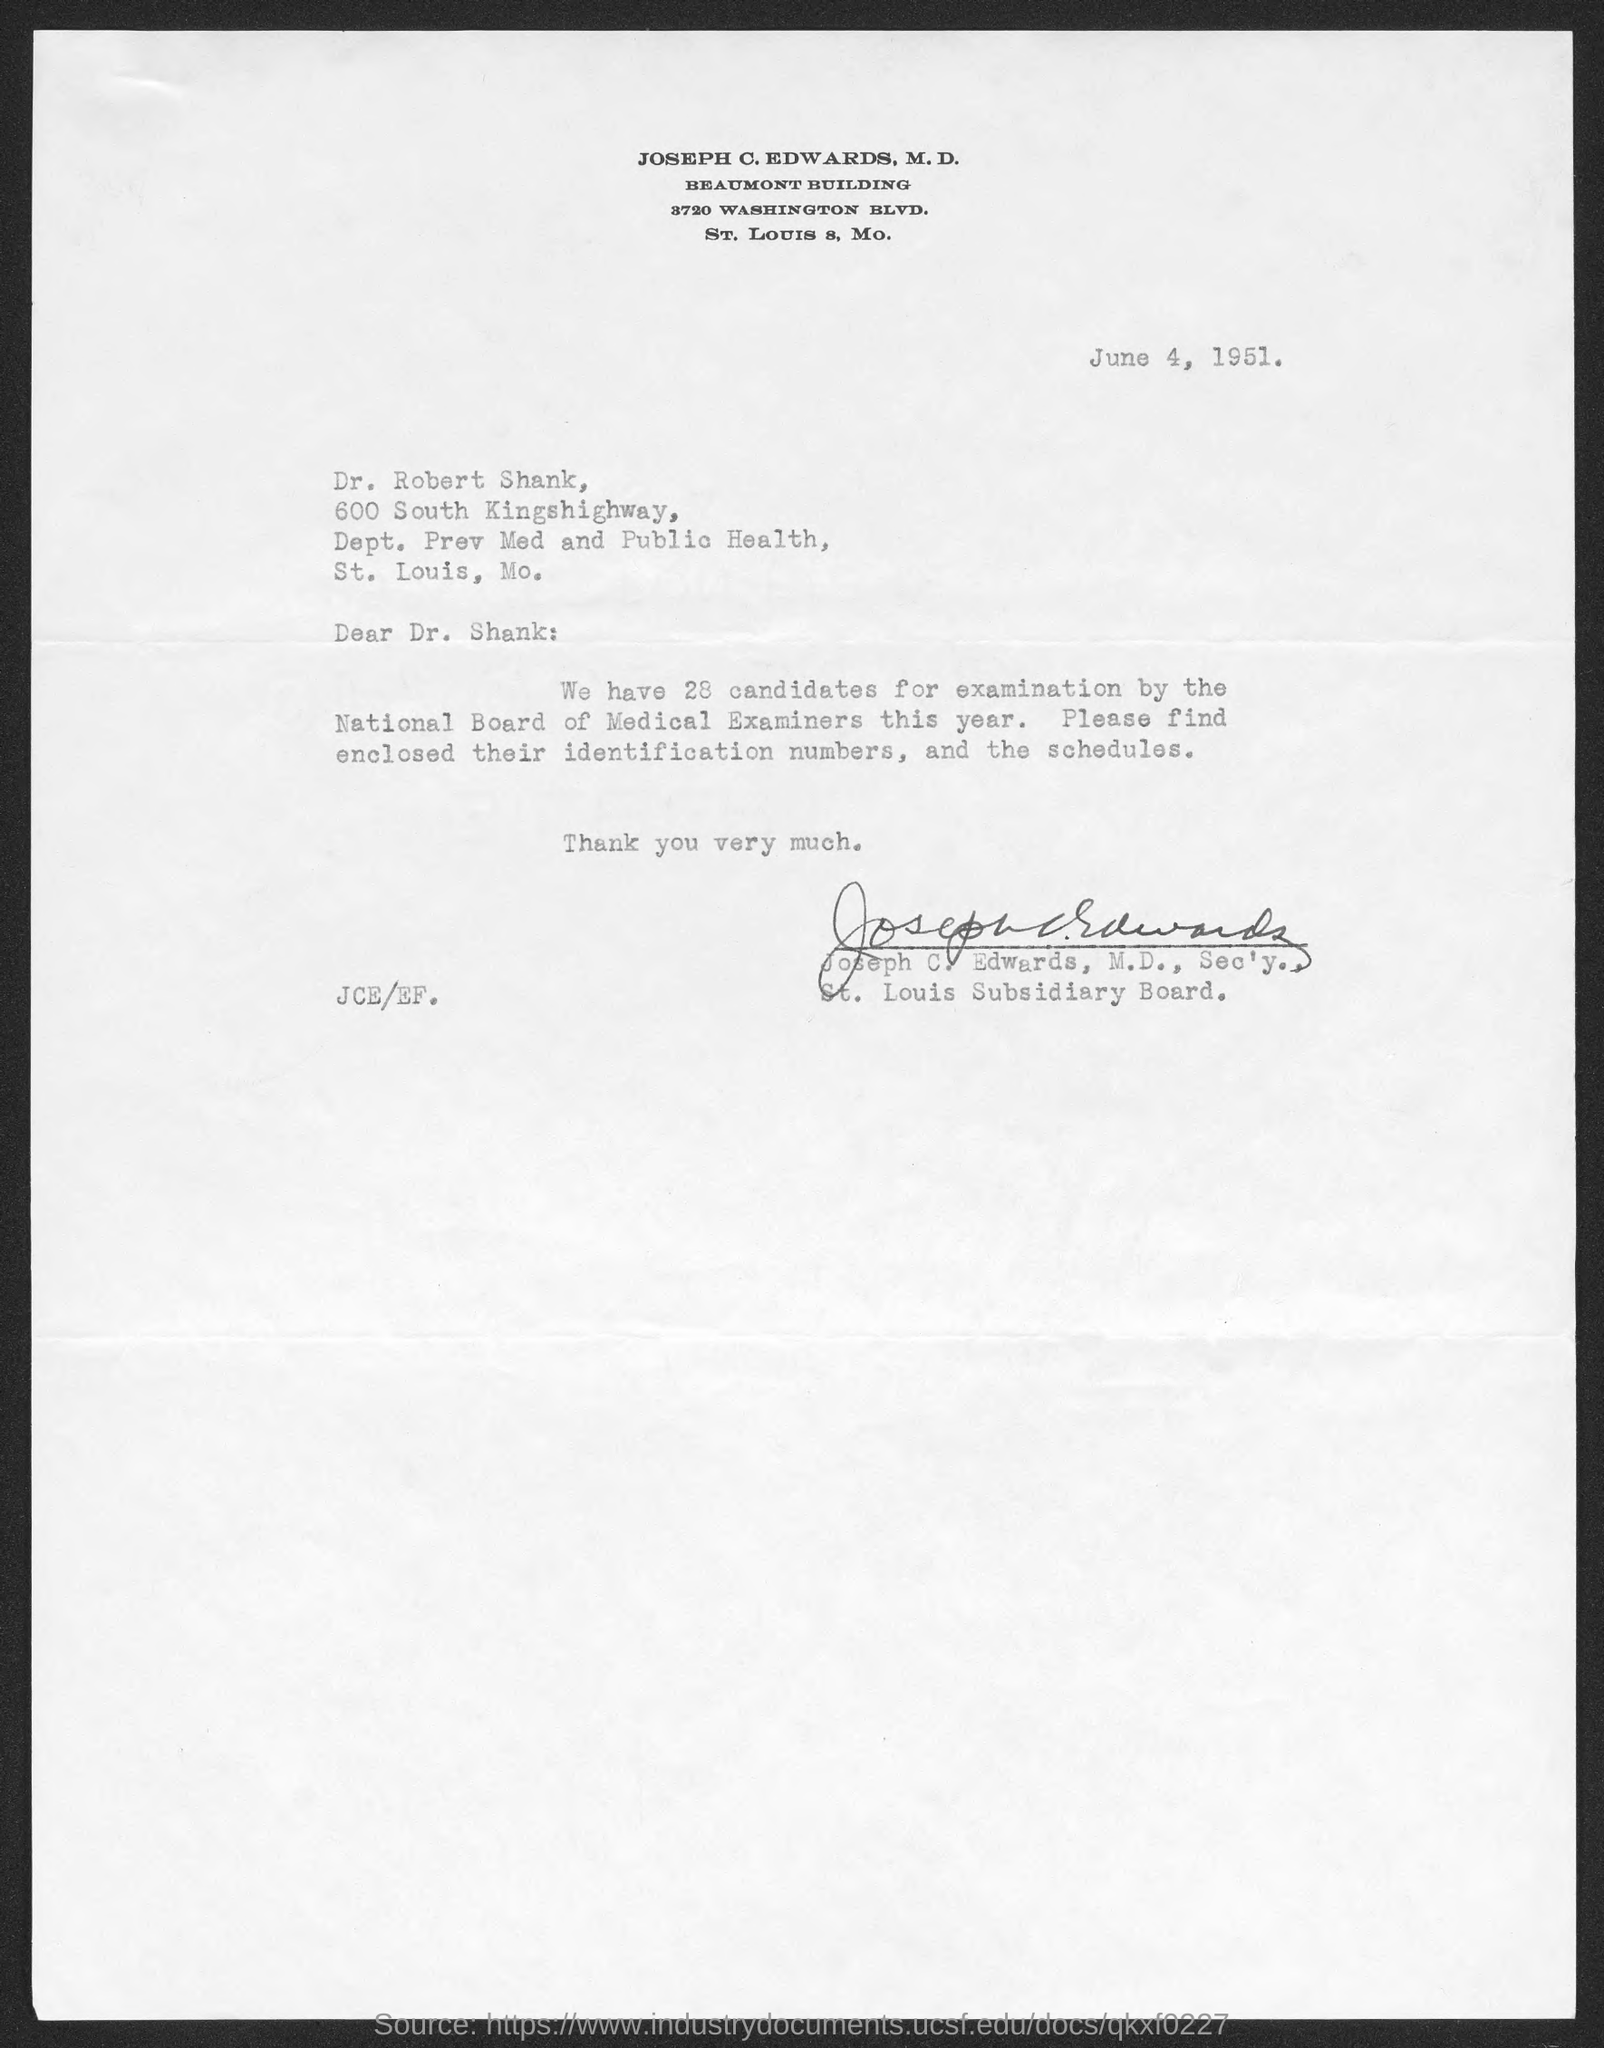When is the memorandum dated on ?
Give a very brief answer. June 4, 1951. 